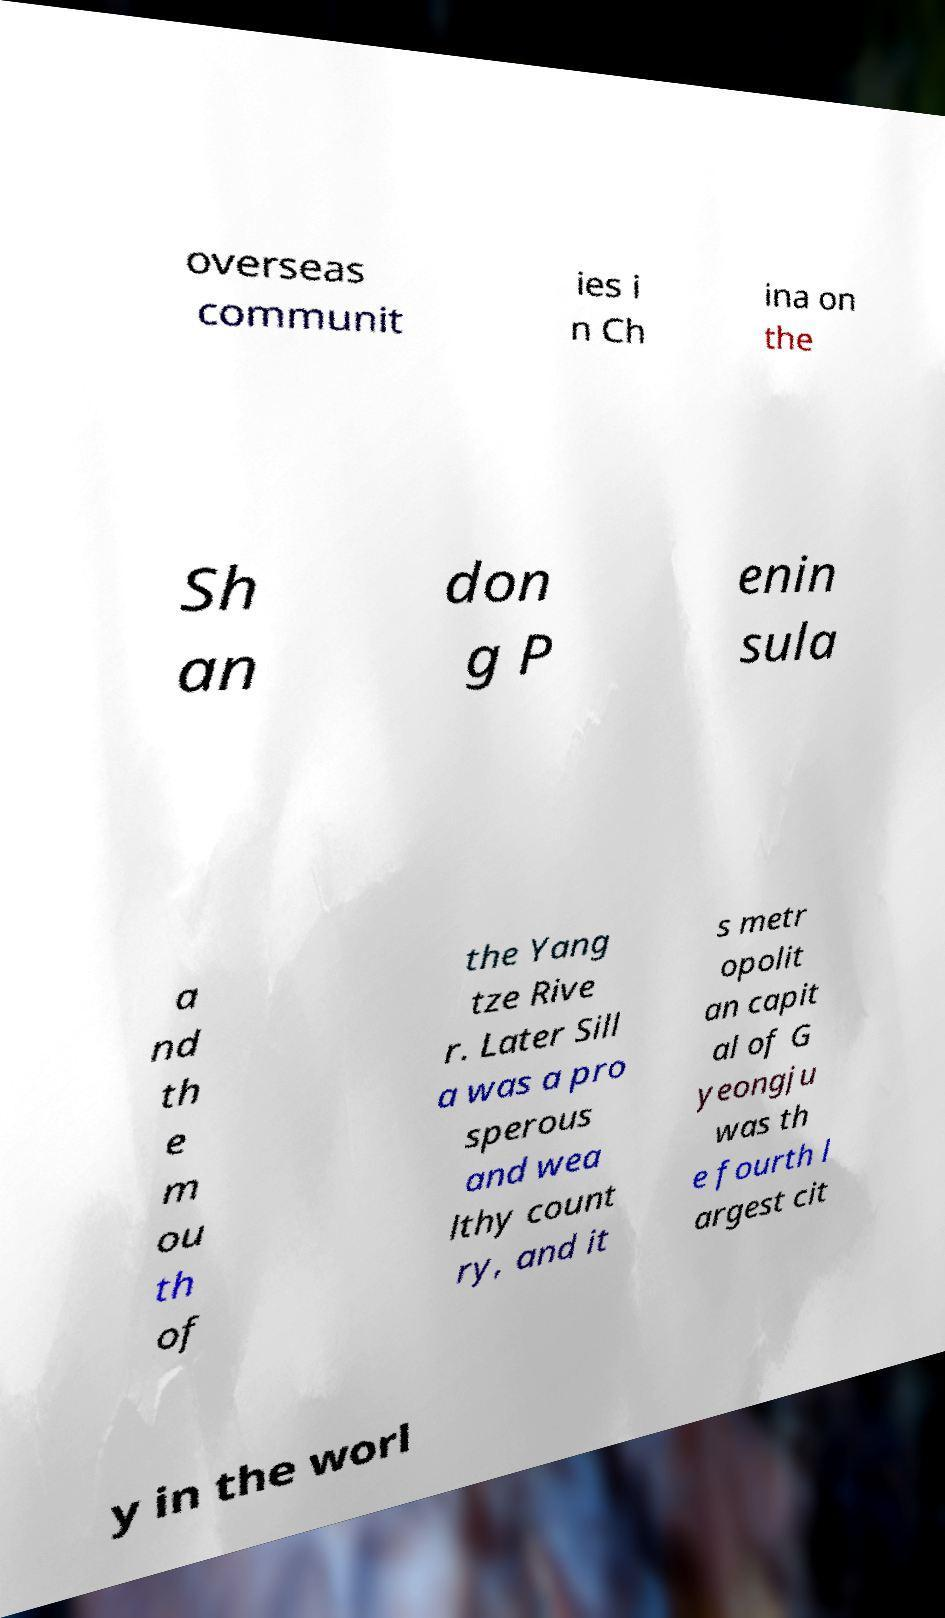What messages or text are displayed in this image? I need them in a readable, typed format. overseas communit ies i n Ch ina on the Sh an don g P enin sula a nd th e m ou th of the Yang tze Rive r. Later Sill a was a pro sperous and wea lthy count ry, and it s metr opolit an capit al of G yeongju was th e fourth l argest cit y in the worl 